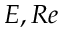Convert formula to latex. <formula><loc_0><loc_0><loc_500><loc_500>E , R e</formula> 